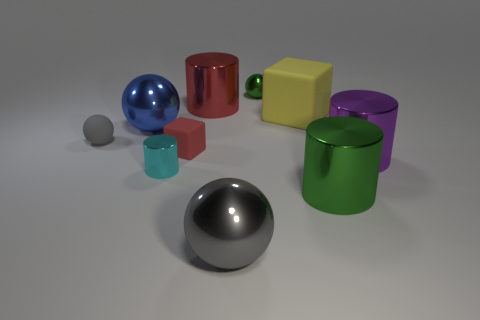What shape is the tiny thing that is both behind the red cube and in front of the big yellow matte block?
Provide a short and direct response. Sphere. What shape is the green object that is to the right of the tiny green metal ball?
Provide a succinct answer. Cylinder. There is a cylinder left of the big cylinder on the left side of the shiny sphere that is in front of the small cube; how big is it?
Your answer should be very brief. Small. Do the small gray object and the cyan shiny thing have the same shape?
Your answer should be very brief. No. How big is the metallic object that is on the right side of the blue sphere and left of the large red shiny object?
Provide a succinct answer. Small. There is another large object that is the same shape as the blue metallic thing; what is it made of?
Ensure brevity in your answer.  Metal. There is a big cylinder that is behind the tiny object to the left of the cyan shiny object; what is its material?
Give a very brief answer. Metal. Does the yellow rubber thing have the same shape as the small metal thing that is to the right of the gray metallic thing?
Give a very brief answer. No. What number of matte things are either yellow cubes or small cyan cylinders?
Provide a short and direct response. 1. What color is the large shiny ball that is to the left of the big metal cylinder on the left side of the big metallic sphere to the right of the big blue metallic object?
Offer a terse response. Blue. 